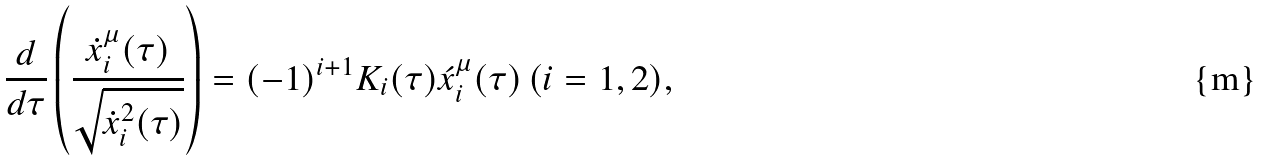<formula> <loc_0><loc_0><loc_500><loc_500>\frac { d } { d \tau } \left ( \frac { \dot { x } _ { i } ^ { \mu } ( \tau ) } { \sqrt { \dot { x } _ { i } ^ { 2 } ( \tau ) } } \right ) = ( - 1 ) ^ { i + 1 } K _ { i } ( \tau ) \acute { x } _ { i } ^ { \mu } ( \tau ) \, ( i = 1 , 2 ) ,</formula> 